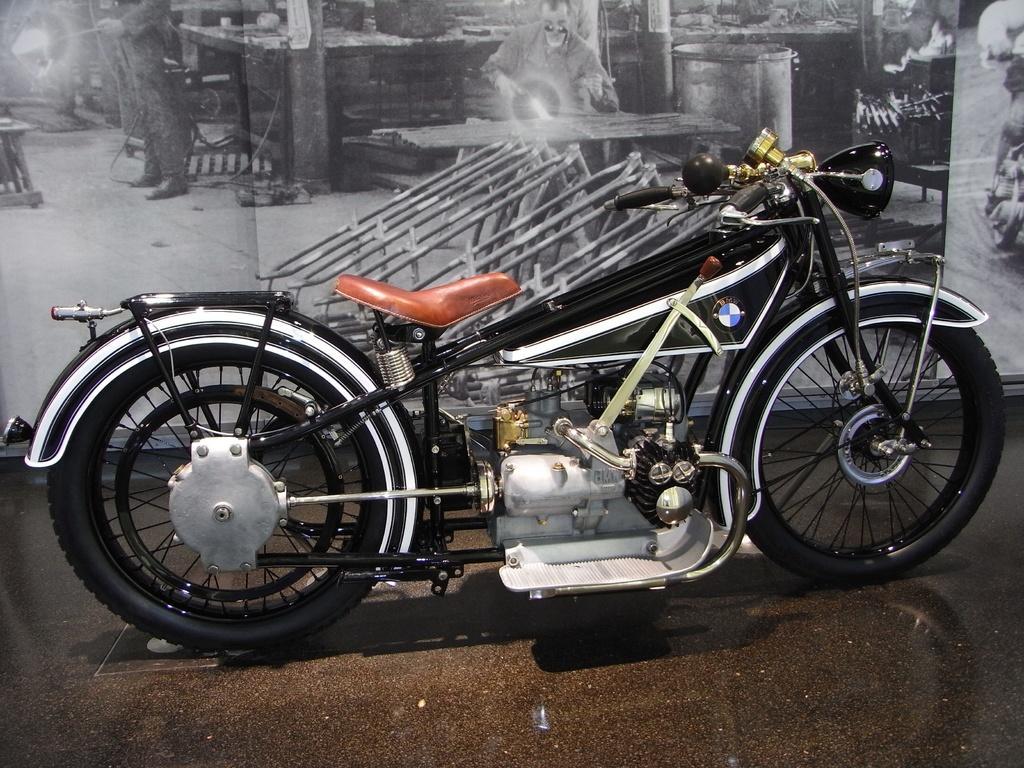How would you summarize this image in a sentence or two? In the image there is a vehicle on the floor and in the background there is a poster with some depictions. 